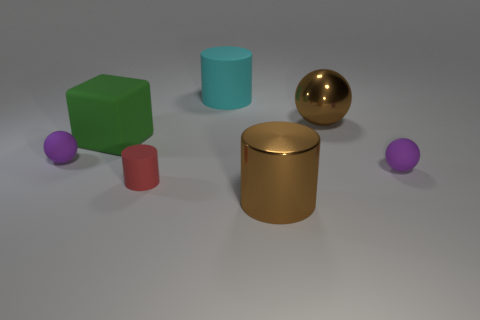Subtract all cyan cylinders. Subtract all brown cubes. How many cylinders are left? 2 Add 2 small blue shiny things. How many objects exist? 9 Subtract all cubes. How many objects are left? 6 Subtract 0 red blocks. How many objects are left? 7 Subtract all big blue matte cylinders. Subtract all metal things. How many objects are left? 5 Add 3 brown shiny cylinders. How many brown shiny cylinders are left? 4 Add 6 large cyan things. How many large cyan things exist? 7 